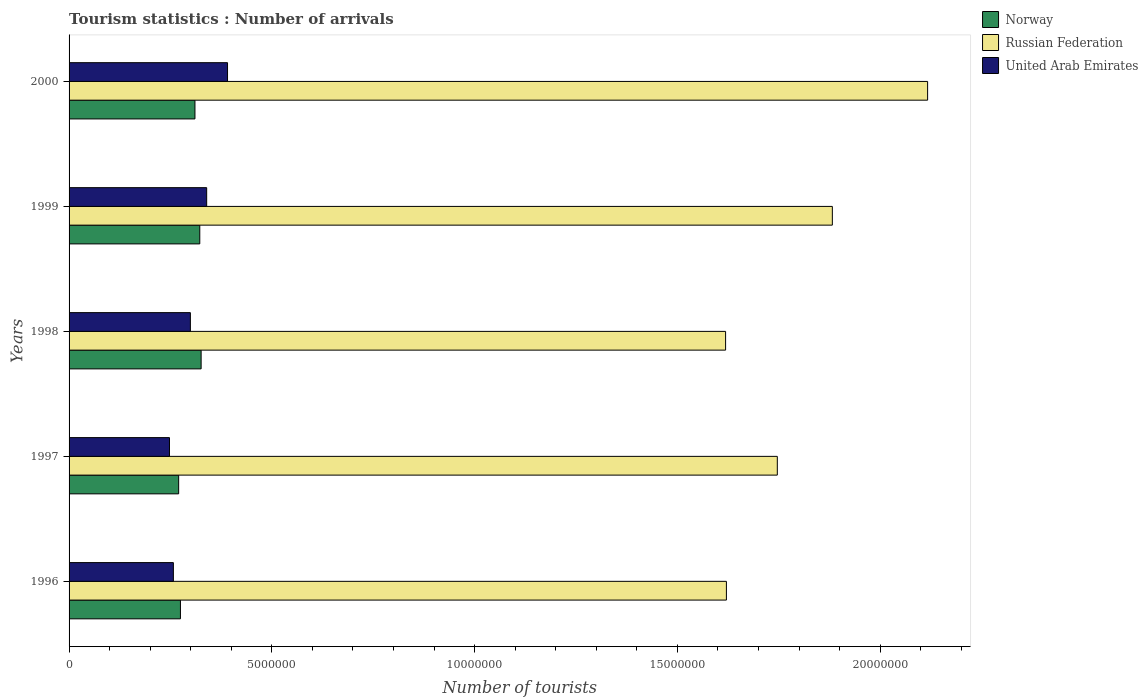How many different coloured bars are there?
Provide a succinct answer. 3. How many groups of bars are there?
Keep it short and to the point. 5. How many bars are there on the 5th tick from the top?
Offer a very short reply. 3. What is the label of the 5th group of bars from the top?
Make the answer very short. 1996. In how many cases, is the number of bars for a given year not equal to the number of legend labels?
Offer a very short reply. 0. What is the number of tourist arrivals in Norway in 2000?
Ensure brevity in your answer.  3.10e+06. Across all years, what is the maximum number of tourist arrivals in Norway?
Offer a terse response. 3.26e+06. Across all years, what is the minimum number of tourist arrivals in Norway?
Your response must be concise. 2.70e+06. What is the total number of tourist arrivals in United Arab Emirates in the graph?
Your answer should be very brief. 1.53e+07. What is the difference between the number of tourist arrivals in Russian Federation in 1997 and that in 1999?
Give a very brief answer. -1.36e+06. What is the difference between the number of tourist arrivals in Norway in 1996 and the number of tourist arrivals in Russian Federation in 2000?
Offer a very short reply. -1.84e+07. What is the average number of tourist arrivals in United Arab Emirates per year?
Make the answer very short. 3.07e+06. In the year 2000, what is the difference between the number of tourist arrivals in Russian Federation and number of tourist arrivals in United Arab Emirates?
Offer a terse response. 1.73e+07. In how many years, is the number of tourist arrivals in United Arab Emirates greater than 10000000 ?
Give a very brief answer. 0. What is the ratio of the number of tourist arrivals in Norway in 1998 to that in 2000?
Make the answer very short. 1.05. Is the number of tourist arrivals in Norway in 1996 less than that in 2000?
Provide a short and direct response. Yes. What is the difference between the highest and the second highest number of tourist arrivals in United Arab Emirates?
Your answer should be compact. 5.14e+05. What is the difference between the highest and the lowest number of tourist arrivals in Russian Federation?
Your answer should be very brief. 4.98e+06. What does the 2nd bar from the top in 1998 represents?
Your answer should be compact. Russian Federation. What does the 2nd bar from the bottom in 1999 represents?
Give a very brief answer. Russian Federation. How many bars are there?
Ensure brevity in your answer.  15. Are all the bars in the graph horizontal?
Make the answer very short. Yes. How many years are there in the graph?
Your answer should be compact. 5. Are the values on the major ticks of X-axis written in scientific E-notation?
Your response must be concise. No. Does the graph contain any zero values?
Give a very brief answer. No. Does the graph contain grids?
Your answer should be very brief. No. How many legend labels are there?
Keep it short and to the point. 3. What is the title of the graph?
Provide a short and direct response. Tourism statistics : Number of arrivals. What is the label or title of the X-axis?
Your answer should be very brief. Number of tourists. What is the label or title of the Y-axis?
Offer a terse response. Years. What is the Number of tourists of Norway in 1996?
Ensure brevity in your answer.  2.75e+06. What is the Number of tourists of Russian Federation in 1996?
Your response must be concise. 1.62e+07. What is the Number of tourists in United Arab Emirates in 1996?
Keep it short and to the point. 2.57e+06. What is the Number of tourists in Norway in 1997?
Give a very brief answer. 2.70e+06. What is the Number of tourists of Russian Federation in 1997?
Your answer should be compact. 1.75e+07. What is the Number of tourists of United Arab Emirates in 1997?
Offer a very short reply. 2.48e+06. What is the Number of tourists of Norway in 1998?
Keep it short and to the point. 3.26e+06. What is the Number of tourists of Russian Federation in 1998?
Ensure brevity in your answer.  1.62e+07. What is the Number of tourists in United Arab Emirates in 1998?
Offer a very short reply. 2.99e+06. What is the Number of tourists of Norway in 1999?
Give a very brief answer. 3.22e+06. What is the Number of tourists of Russian Federation in 1999?
Offer a terse response. 1.88e+07. What is the Number of tourists of United Arab Emirates in 1999?
Make the answer very short. 3.39e+06. What is the Number of tourists of Norway in 2000?
Your answer should be compact. 3.10e+06. What is the Number of tourists in Russian Federation in 2000?
Your response must be concise. 2.12e+07. What is the Number of tourists of United Arab Emirates in 2000?
Provide a succinct answer. 3.91e+06. Across all years, what is the maximum Number of tourists of Norway?
Provide a short and direct response. 3.26e+06. Across all years, what is the maximum Number of tourists of Russian Federation?
Ensure brevity in your answer.  2.12e+07. Across all years, what is the maximum Number of tourists in United Arab Emirates?
Your response must be concise. 3.91e+06. Across all years, what is the minimum Number of tourists of Norway?
Keep it short and to the point. 2.70e+06. Across all years, what is the minimum Number of tourists of Russian Federation?
Ensure brevity in your answer.  1.62e+07. Across all years, what is the minimum Number of tourists in United Arab Emirates?
Make the answer very short. 2.48e+06. What is the total Number of tourists in Norway in the graph?
Give a very brief answer. 1.50e+07. What is the total Number of tourists in Russian Federation in the graph?
Provide a succinct answer. 8.98e+07. What is the total Number of tourists in United Arab Emirates in the graph?
Keep it short and to the point. 1.53e+07. What is the difference between the Number of tourists of Norway in 1996 and that in 1997?
Give a very brief answer. 4.40e+04. What is the difference between the Number of tourists of Russian Federation in 1996 and that in 1997?
Your answer should be very brief. -1.26e+06. What is the difference between the Number of tourists in United Arab Emirates in 1996 and that in 1997?
Make the answer very short. 9.60e+04. What is the difference between the Number of tourists in Norway in 1996 and that in 1998?
Your answer should be very brief. -5.10e+05. What is the difference between the Number of tourists in United Arab Emirates in 1996 and that in 1998?
Offer a very short reply. -4.19e+05. What is the difference between the Number of tourists of Norway in 1996 and that in 1999?
Your answer should be compact. -4.77e+05. What is the difference between the Number of tourists of Russian Federation in 1996 and that in 1999?
Offer a terse response. -2.61e+06. What is the difference between the Number of tourists in United Arab Emirates in 1996 and that in 1999?
Ensure brevity in your answer.  -8.21e+05. What is the difference between the Number of tourists of Norway in 1996 and that in 2000?
Make the answer very short. -3.58e+05. What is the difference between the Number of tourists in Russian Federation in 1996 and that in 2000?
Offer a very short reply. -4.96e+06. What is the difference between the Number of tourists in United Arab Emirates in 1996 and that in 2000?
Provide a succinct answer. -1.34e+06. What is the difference between the Number of tourists of Norway in 1997 and that in 1998?
Your answer should be compact. -5.54e+05. What is the difference between the Number of tourists of Russian Federation in 1997 and that in 1998?
Your response must be concise. 1.28e+06. What is the difference between the Number of tourists of United Arab Emirates in 1997 and that in 1998?
Provide a succinct answer. -5.15e+05. What is the difference between the Number of tourists of Norway in 1997 and that in 1999?
Offer a very short reply. -5.21e+05. What is the difference between the Number of tourists in Russian Federation in 1997 and that in 1999?
Offer a very short reply. -1.36e+06. What is the difference between the Number of tourists in United Arab Emirates in 1997 and that in 1999?
Your response must be concise. -9.17e+05. What is the difference between the Number of tourists of Norway in 1997 and that in 2000?
Give a very brief answer. -4.02e+05. What is the difference between the Number of tourists in Russian Federation in 1997 and that in 2000?
Make the answer very short. -3.71e+06. What is the difference between the Number of tourists in United Arab Emirates in 1997 and that in 2000?
Provide a succinct answer. -1.43e+06. What is the difference between the Number of tourists in Norway in 1998 and that in 1999?
Provide a short and direct response. 3.30e+04. What is the difference between the Number of tourists of Russian Federation in 1998 and that in 1999?
Your answer should be compact. -2.63e+06. What is the difference between the Number of tourists of United Arab Emirates in 1998 and that in 1999?
Offer a very short reply. -4.02e+05. What is the difference between the Number of tourists of Norway in 1998 and that in 2000?
Ensure brevity in your answer.  1.52e+05. What is the difference between the Number of tourists of Russian Federation in 1998 and that in 2000?
Your answer should be very brief. -4.98e+06. What is the difference between the Number of tourists of United Arab Emirates in 1998 and that in 2000?
Offer a terse response. -9.16e+05. What is the difference between the Number of tourists in Norway in 1999 and that in 2000?
Offer a very short reply. 1.19e+05. What is the difference between the Number of tourists in Russian Federation in 1999 and that in 2000?
Your answer should be very brief. -2.35e+06. What is the difference between the Number of tourists of United Arab Emirates in 1999 and that in 2000?
Keep it short and to the point. -5.14e+05. What is the difference between the Number of tourists in Norway in 1996 and the Number of tourists in Russian Federation in 1997?
Keep it short and to the point. -1.47e+07. What is the difference between the Number of tourists of Norway in 1996 and the Number of tourists of United Arab Emirates in 1997?
Your answer should be compact. 2.70e+05. What is the difference between the Number of tourists in Russian Federation in 1996 and the Number of tourists in United Arab Emirates in 1997?
Ensure brevity in your answer.  1.37e+07. What is the difference between the Number of tourists in Norway in 1996 and the Number of tourists in Russian Federation in 1998?
Your answer should be compact. -1.34e+07. What is the difference between the Number of tourists of Norway in 1996 and the Number of tourists of United Arab Emirates in 1998?
Your response must be concise. -2.45e+05. What is the difference between the Number of tourists in Russian Federation in 1996 and the Number of tourists in United Arab Emirates in 1998?
Keep it short and to the point. 1.32e+07. What is the difference between the Number of tourists in Norway in 1996 and the Number of tourists in Russian Federation in 1999?
Offer a terse response. -1.61e+07. What is the difference between the Number of tourists of Norway in 1996 and the Number of tourists of United Arab Emirates in 1999?
Make the answer very short. -6.47e+05. What is the difference between the Number of tourists in Russian Federation in 1996 and the Number of tourists in United Arab Emirates in 1999?
Your answer should be compact. 1.28e+07. What is the difference between the Number of tourists in Norway in 1996 and the Number of tourists in Russian Federation in 2000?
Give a very brief answer. -1.84e+07. What is the difference between the Number of tourists of Norway in 1996 and the Number of tourists of United Arab Emirates in 2000?
Ensure brevity in your answer.  -1.16e+06. What is the difference between the Number of tourists of Russian Federation in 1996 and the Number of tourists of United Arab Emirates in 2000?
Your response must be concise. 1.23e+07. What is the difference between the Number of tourists of Norway in 1997 and the Number of tourists of Russian Federation in 1998?
Provide a short and direct response. -1.35e+07. What is the difference between the Number of tourists of Norway in 1997 and the Number of tourists of United Arab Emirates in 1998?
Your answer should be compact. -2.89e+05. What is the difference between the Number of tourists of Russian Federation in 1997 and the Number of tourists of United Arab Emirates in 1998?
Offer a terse response. 1.45e+07. What is the difference between the Number of tourists in Norway in 1997 and the Number of tourists in Russian Federation in 1999?
Provide a succinct answer. -1.61e+07. What is the difference between the Number of tourists in Norway in 1997 and the Number of tourists in United Arab Emirates in 1999?
Provide a succinct answer. -6.91e+05. What is the difference between the Number of tourists in Russian Federation in 1997 and the Number of tourists in United Arab Emirates in 1999?
Provide a succinct answer. 1.41e+07. What is the difference between the Number of tourists of Norway in 1997 and the Number of tourists of Russian Federation in 2000?
Make the answer very short. -1.85e+07. What is the difference between the Number of tourists of Norway in 1997 and the Number of tourists of United Arab Emirates in 2000?
Offer a very short reply. -1.20e+06. What is the difference between the Number of tourists of Russian Federation in 1997 and the Number of tourists of United Arab Emirates in 2000?
Offer a very short reply. 1.36e+07. What is the difference between the Number of tourists in Norway in 1998 and the Number of tourists in Russian Federation in 1999?
Offer a terse response. -1.56e+07. What is the difference between the Number of tourists in Norway in 1998 and the Number of tourists in United Arab Emirates in 1999?
Offer a very short reply. -1.37e+05. What is the difference between the Number of tourists of Russian Federation in 1998 and the Number of tourists of United Arab Emirates in 1999?
Provide a short and direct response. 1.28e+07. What is the difference between the Number of tourists in Norway in 1998 and the Number of tourists in Russian Federation in 2000?
Provide a short and direct response. -1.79e+07. What is the difference between the Number of tourists of Norway in 1998 and the Number of tourists of United Arab Emirates in 2000?
Your answer should be very brief. -6.51e+05. What is the difference between the Number of tourists in Russian Federation in 1998 and the Number of tourists in United Arab Emirates in 2000?
Your answer should be very brief. 1.23e+07. What is the difference between the Number of tourists of Norway in 1999 and the Number of tourists of Russian Federation in 2000?
Give a very brief answer. -1.79e+07. What is the difference between the Number of tourists in Norway in 1999 and the Number of tourists in United Arab Emirates in 2000?
Give a very brief answer. -6.84e+05. What is the difference between the Number of tourists in Russian Federation in 1999 and the Number of tourists in United Arab Emirates in 2000?
Your answer should be very brief. 1.49e+07. What is the average Number of tourists of Norway per year?
Offer a very short reply. 3.01e+06. What is the average Number of tourists of Russian Federation per year?
Your response must be concise. 1.80e+07. What is the average Number of tourists of United Arab Emirates per year?
Your answer should be compact. 3.07e+06. In the year 1996, what is the difference between the Number of tourists in Norway and Number of tourists in Russian Federation?
Offer a terse response. -1.35e+07. In the year 1996, what is the difference between the Number of tourists in Norway and Number of tourists in United Arab Emirates?
Provide a short and direct response. 1.74e+05. In the year 1996, what is the difference between the Number of tourists of Russian Federation and Number of tourists of United Arab Emirates?
Provide a succinct answer. 1.36e+07. In the year 1997, what is the difference between the Number of tourists of Norway and Number of tourists of Russian Federation?
Provide a short and direct response. -1.48e+07. In the year 1997, what is the difference between the Number of tourists of Norway and Number of tourists of United Arab Emirates?
Provide a short and direct response. 2.26e+05. In the year 1997, what is the difference between the Number of tourists in Russian Federation and Number of tourists in United Arab Emirates?
Your response must be concise. 1.50e+07. In the year 1998, what is the difference between the Number of tourists in Norway and Number of tourists in Russian Federation?
Provide a short and direct response. -1.29e+07. In the year 1998, what is the difference between the Number of tourists in Norway and Number of tourists in United Arab Emirates?
Make the answer very short. 2.65e+05. In the year 1998, what is the difference between the Number of tourists in Russian Federation and Number of tourists in United Arab Emirates?
Offer a very short reply. 1.32e+07. In the year 1999, what is the difference between the Number of tourists of Norway and Number of tourists of Russian Federation?
Keep it short and to the point. -1.56e+07. In the year 1999, what is the difference between the Number of tourists in Russian Federation and Number of tourists in United Arab Emirates?
Your answer should be very brief. 1.54e+07. In the year 2000, what is the difference between the Number of tourists in Norway and Number of tourists in Russian Federation?
Provide a succinct answer. -1.81e+07. In the year 2000, what is the difference between the Number of tourists in Norway and Number of tourists in United Arab Emirates?
Provide a succinct answer. -8.03e+05. In the year 2000, what is the difference between the Number of tourists in Russian Federation and Number of tourists in United Arab Emirates?
Keep it short and to the point. 1.73e+07. What is the ratio of the Number of tourists in Norway in 1996 to that in 1997?
Your answer should be very brief. 1.02. What is the ratio of the Number of tourists in Russian Federation in 1996 to that in 1997?
Offer a terse response. 0.93. What is the ratio of the Number of tourists in United Arab Emirates in 1996 to that in 1997?
Give a very brief answer. 1.04. What is the ratio of the Number of tourists in Norway in 1996 to that in 1998?
Your response must be concise. 0.84. What is the ratio of the Number of tourists of Russian Federation in 1996 to that in 1998?
Offer a very short reply. 1. What is the ratio of the Number of tourists of United Arab Emirates in 1996 to that in 1998?
Your answer should be compact. 0.86. What is the ratio of the Number of tourists of Norway in 1996 to that in 1999?
Offer a very short reply. 0.85. What is the ratio of the Number of tourists in Russian Federation in 1996 to that in 1999?
Your answer should be very brief. 0.86. What is the ratio of the Number of tourists of United Arab Emirates in 1996 to that in 1999?
Provide a short and direct response. 0.76. What is the ratio of the Number of tourists in Norway in 1996 to that in 2000?
Offer a very short reply. 0.88. What is the ratio of the Number of tourists in Russian Federation in 1996 to that in 2000?
Keep it short and to the point. 0.77. What is the ratio of the Number of tourists in United Arab Emirates in 1996 to that in 2000?
Keep it short and to the point. 0.66. What is the ratio of the Number of tourists in Norway in 1997 to that in 1998?
Your response must be concise. 0.83. What is the ratio of the Number of tourists of Russian Federation in 1997 to that in 1998?
Offer a very short reply. 1.08. What is the ratio of the Number of tourists of United Arab Emirates in 1997 to that in 1998?
Offer a very short reply. 0.83. What is the ratio of the Number of tourists in Norway in 1997 to that in 1999?
Offer a very short reply. 0.84. What is the ratio of the Number of tourists in Russian Federation in 1997 to that in 1999?
Provide a short and direct response. 0.93. What is the ratio of the Number of tourists of United Arab Emirates in 1997 to that in 1999?
Offer a terse response. 0.73. What is the ratio of the Number of tourists of Norway in 1997 to that in 2000?
Your answer should be very brief. 0.87. What is the ratio of the Number of tourists in Russian Federation in 1997 to that in 2000?
Your response must be concise. 0.82. What is the ratio of the Number of tourists in United Arab Emirates in 1997 to that in 2000?
Provide a short and direct response. 0.63. What is the ratio of the Number of tourists of Norway in 1998 to that in 1999?
Provide a short and direct response. 1.01. What is the ratio of the Number of tourists in Russian Federation in 1998 to that in 1999?
Your response must be concise. 0.86. What is the ratio of the Number of tourists in United Arab Emirates in 1998 to that in 1999?
Your answer should be very brief. 0.88. What is the ratio of the Number of tourists in Norway in 1998 to that in 2000?
Provide a succinct answer. 1.05. What is the ratio of the Number of tourists in Russian Federation in 1998 to that in 2000?
Offer a very short reply. 0.76. What is the ratio of the Number of tourists of United Arab Emirates in 1998 to that in 2000?
Offer a terse response. 0.77. What is the ratio of the Number of tourists of Norway in 1999 to that in 2000?
Your response must be concise. 1.04. What is the ratio of the Number of tourists in Russian Federation in 1999 to that in 2000?
Make the answer very short. 0.89. What is the ratio of the Number of tourists of United Arab Emirates in 1999 to that in 2000?
Your response must be concise. 0.87. What is the difference between the highest and the second highest Number of tourists in Norway?
Give a very brief answer. 3.30e+04. What is the difference between the highest and the second highest Number of tourists of Russian Federation?
Your response must be concise. 2.35e+06. What is the difference between the highest and the second highest Number of tourists in United Arab Emirates?
Keep it short and to the point. 5.14e+05. What is the difference between the highest and the lowest Number of tourists in Norway?
Your answer should be compact. 5.54e+05. What is the difference between the highest and the lowest Number of tourists in Russian Federation?
Offer a very short reply. 4.98e+06. What is the difference between the highest and the lowest Number of tourists of United Arab Emirates?
Provide a short and direct response. 1.43e+06. 